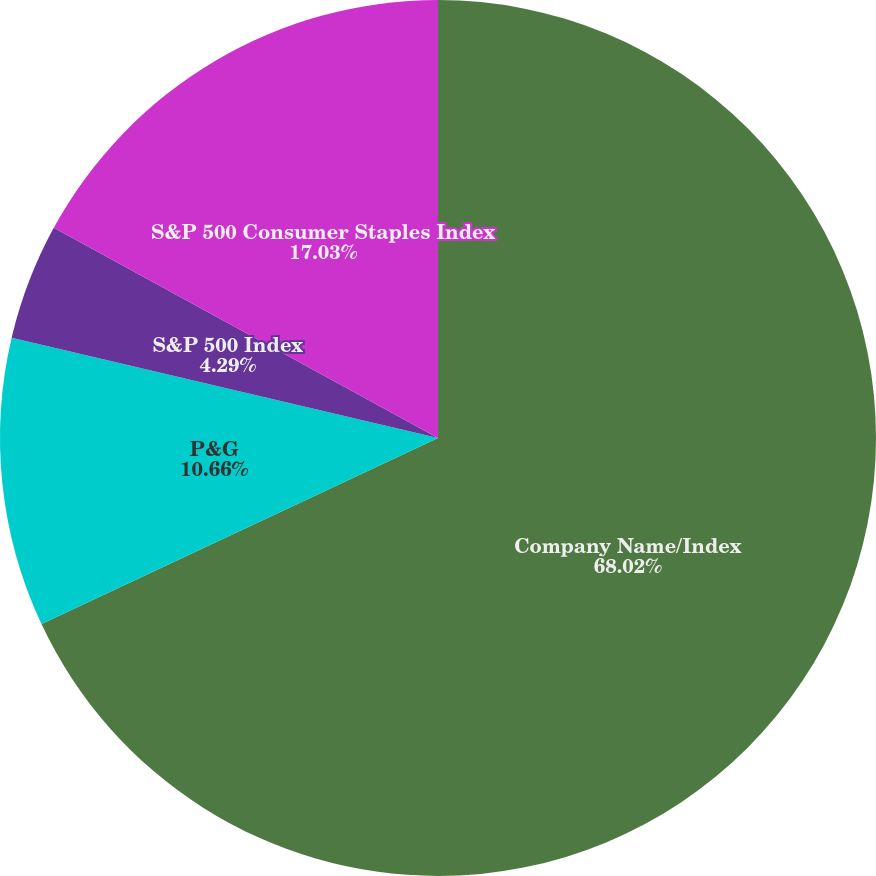Convert chart to OTSL. <chart><loc_0><loc_0><loc_500><loc_500><pie_chart><fcel>Company Name/Index<fcel>P&G<fcel>S&P 500 Index<fcel>S&P 500 Consumer Staples Index<nl><fcel>68.01%<fcel>10.66%<fcel>4.29%<fcel>17.03%<nl></chart> 